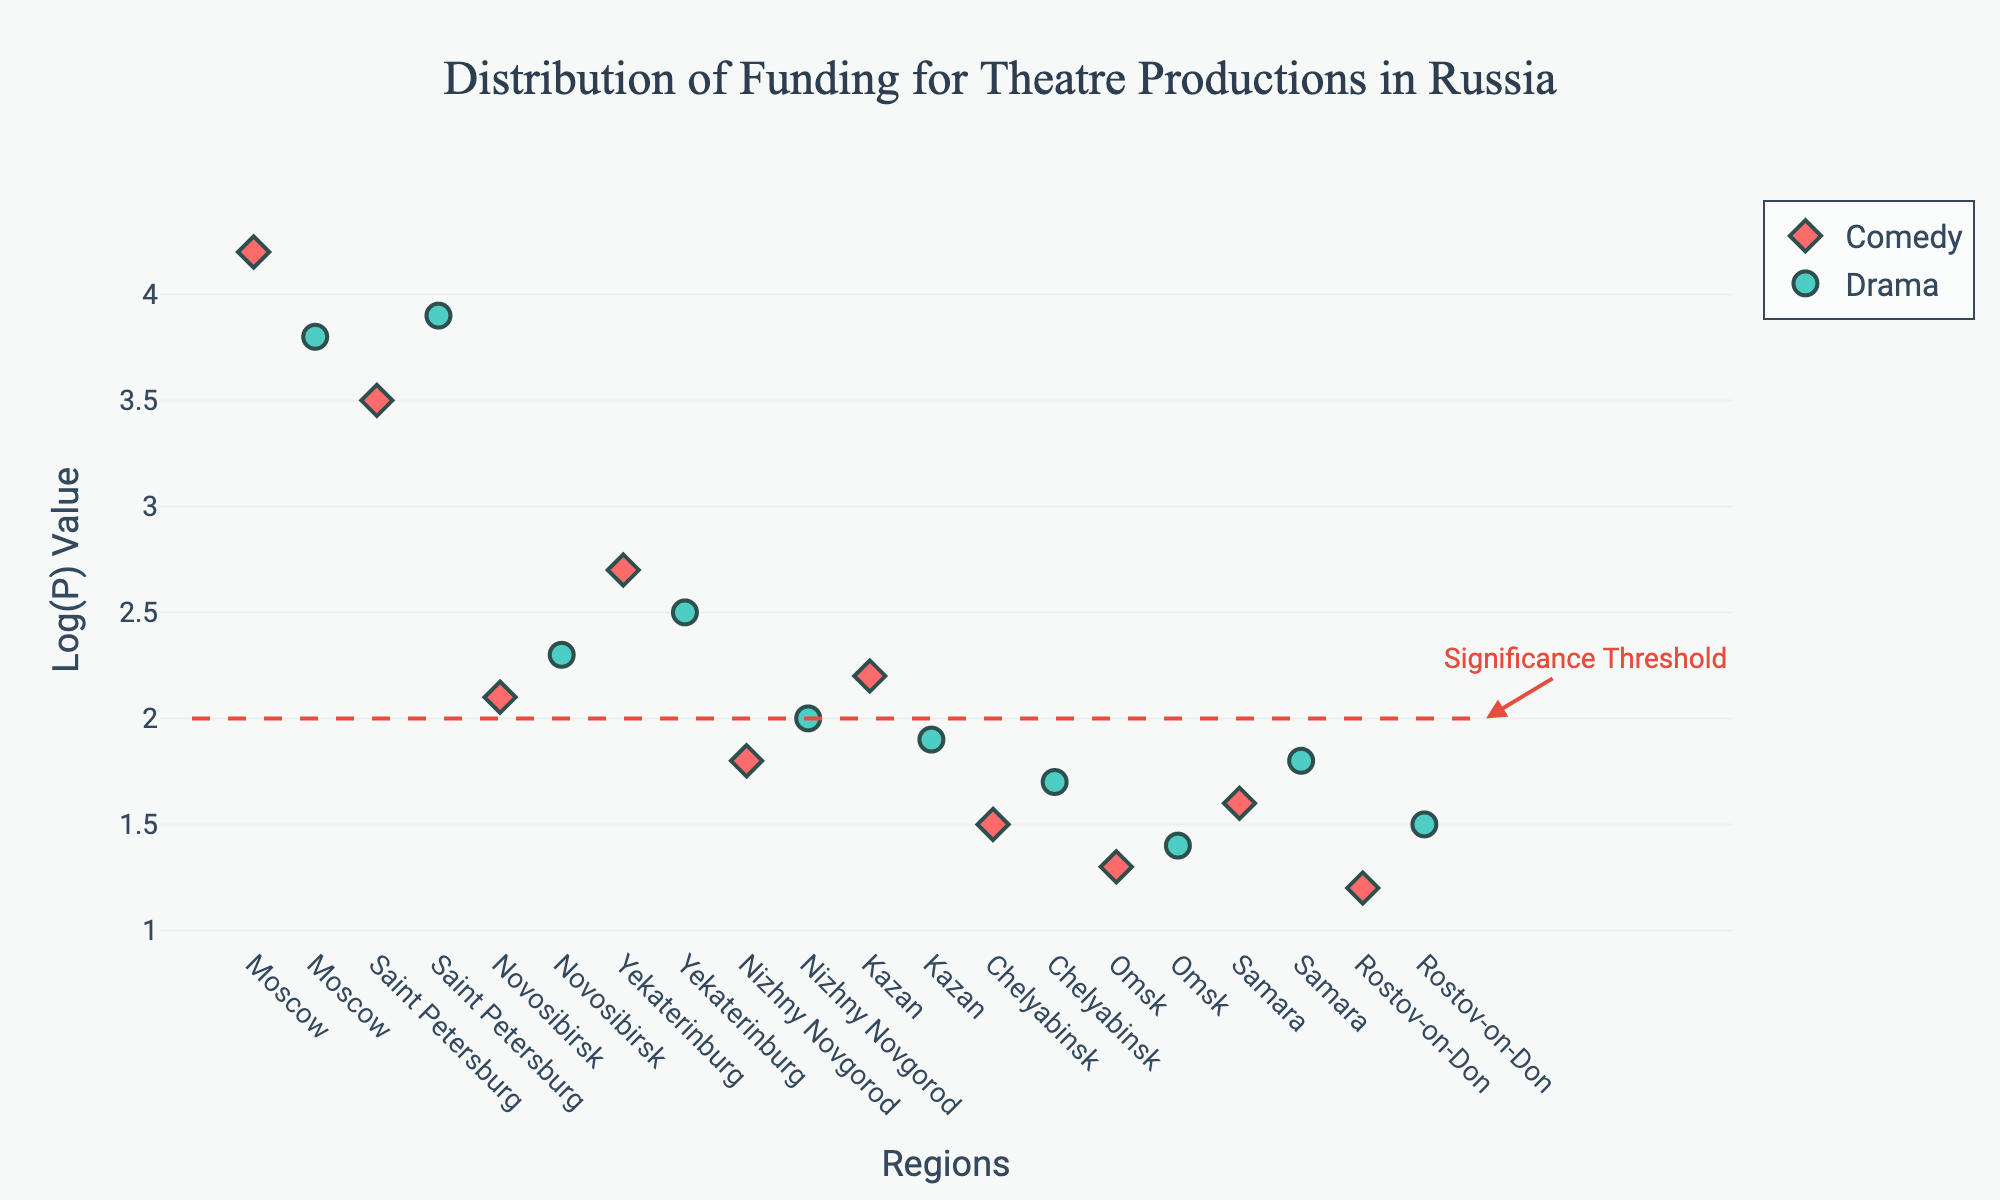What is the title of the plot? The title is located at the top of the plot and reads: "Distribution of Funding for Theatre Productions in Russia".
Answer: Distribution of Funding for Theatre Productions in Russia How many total regions are represented in the plot? Each tick on the x-axis represents a different region. By counting the tick labels, there are 10 regions in total: Moscow, Saint Petersburg, Novosibirsk, Yekaterinburg, Nizhny Novgorod, Kazan, Chelyabinsk, Omsk, Samara, and Rostov-on-Don.
Answer: 10 Which genre has the highest funding in Moscow? Look for the points labeled ‘Moscow’ and compare their Log(P) values. Comedy has a Log(P) value of 4.2, whereas Drama has 3.8.
Answer: Comedy In which region do both genres have funding levels below the significance threshold? The significance threshold line is at y=2. For a region to meet this criterion, both its Comedy and Drama Log(P) values must be below 2. Only Rostov-on-Don has both values below the threshold (Comedy=1.2, Drama=1.5).
Answer: Rostov-on-Don What is the Log(P) value for Comedy in Saint Petersburg? The plot shows Comedy in Saint Petersburg at position 3 with a Log(P) value of 3.5.
Answer: 3.5 Identify the regions where the funding level for Drama exceeds the significance threshold. The threshold is at y=2. Check the Log(P) values for Drama in each region. Those exceeding 2 are Moscow (3.8), Saint Petersburg (3.9), Yekaterinburg (2.5), and Novosibirsk (2.3).
Answer: Moscow, Saint Petersburg, Yekaterinburg, and Novosibirsk What is the average Log(P) value for Comedy in regions where its funding exceeds the significance threshold? Comedy values above the threshold (y=2) appear in Moscow (4.2), Saint Petersburg (3.5), Novosibirsk (2.1), Yekaterinburg (2.7), Kazan (2.2), Samara (1.6). The average is (4.2 + 3.5 + 2.1 + 2.7 + 2.2 + 1.6) / 6 = 2.72.
Answer: 2.72 Which genre has more regions exceeding the significance threshold? Count the number of regions for each genre with Log(P) values above 2. Comedy: Moscow, Saint Petersburg, Novosibirsk, Yekaterinburg, Kazan = 5 regions. Drama: Moscow, Saint Petersburg, Yekaterinburg, Novosibirsk = 4 regions.
Answer: Comedy Are there any regions where Comedy and Drama have equal funding levels? Review each region’s Comedy and Drama points; none of the regions have equal Log(P) values for both genres.
Answer: No 